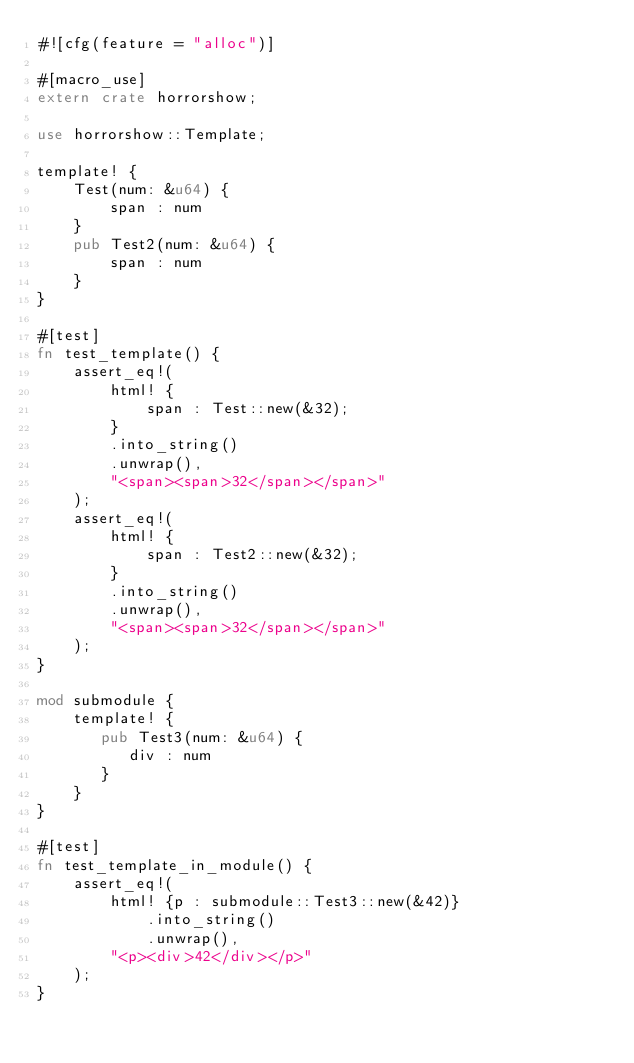Convert code to text. <code><loc_0><loc_0><loc_500><loc_500><_Rust_>#![cfg(feature = "alloc")]

#[macro_use]
extern crate horrorshow;

use horrorshow::Template;

template! {
    Test(num: &u64) {
        span : num
    }
    pub Test2(num: &u64) {
        span : num
    }
}

#[test]
fn test_template() {
    assert_eq!(
        html! {
            span : Test::new(&32);
        }
        .into_string()
        .unwrap(),
        "<span><span>32</span></span>"
    );
    assert_eq!(
        html! {
            span : Test2::new(&32);
        }
        .into_string()
        .unwrap(),
        "<span><span>32</span></span>"
    );
}

mod submodule {
    template! {
       pub Test3(num: &u64) {
          div : num
       }
    }
}

#[test]
fn test_template_in_module() {
    assert_eq!(
        html! {p : submodule::Test3::new(&42)}
            .into_string()
            .unwrap(),
        "<p><div>42</div></p>"
    );
}
</code> 